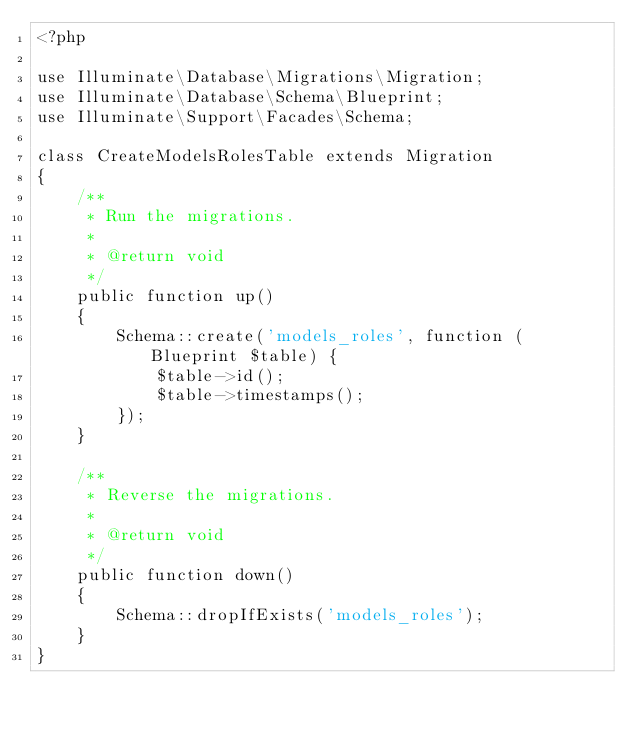<code> <loc_0><loc_0><loc_500><loc_500><_PHP_><?php

use Illuminate\Database\Migrations\Migration;
use Illuminate\Database\Schema\Blueprint;
use Illuminate\Support\Facades\Schema;

class CreateModelsRolesTable extends Migration
{
    /**
     * Run the migrations.
     *
     * @return void
     */
    public function up()
    {
        Schema::create('models_roles', function (Blueprint $table) {
            $table->id();
            $table->timestamps();
        });
    }

    /**
     * Reverse the migrations.
     *
     * @return void
     */
    public function down()
    {
        Schema::dropIfExists('models_roles');
    }
}
</code> 